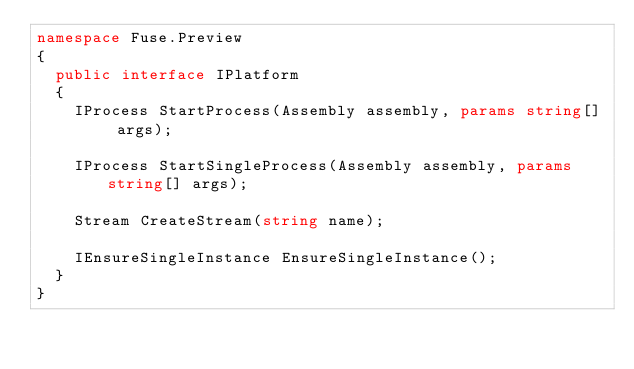Convert code to text. <code><loc_0><loc_0><loc_500><loc_500><_C#_>namespace Fuse.Preview
{
	public interface IPlatform
	{
		IProcess StartProcess(Assembly assembly, params string[] args);
		
		IProcess StartSingleProcess(Assembly assembly, params string[] args);

		Stream CreateStream(string name);

		IEnsureSingleInstance EnsureSingleInstance();
	}
}</code> 